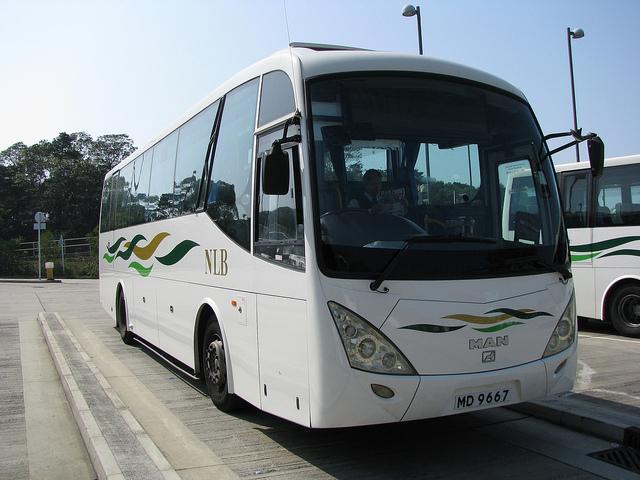How many buses are in this picture?
Concise answer only. 2. What name is on the side of the white bus?
Concise answer only. Nlb. What color is the edge of the bus?
Quick response, please. White. What is the main color of the bus?
Write a very short answer. White. Is this a city bus surrounded by tall buildings?
Answer briefly. No. Is the front window of the bus big?
Concise answer only. Yes. What 3 letters are on the side of the bus?
Quick response, please. Nlb. 